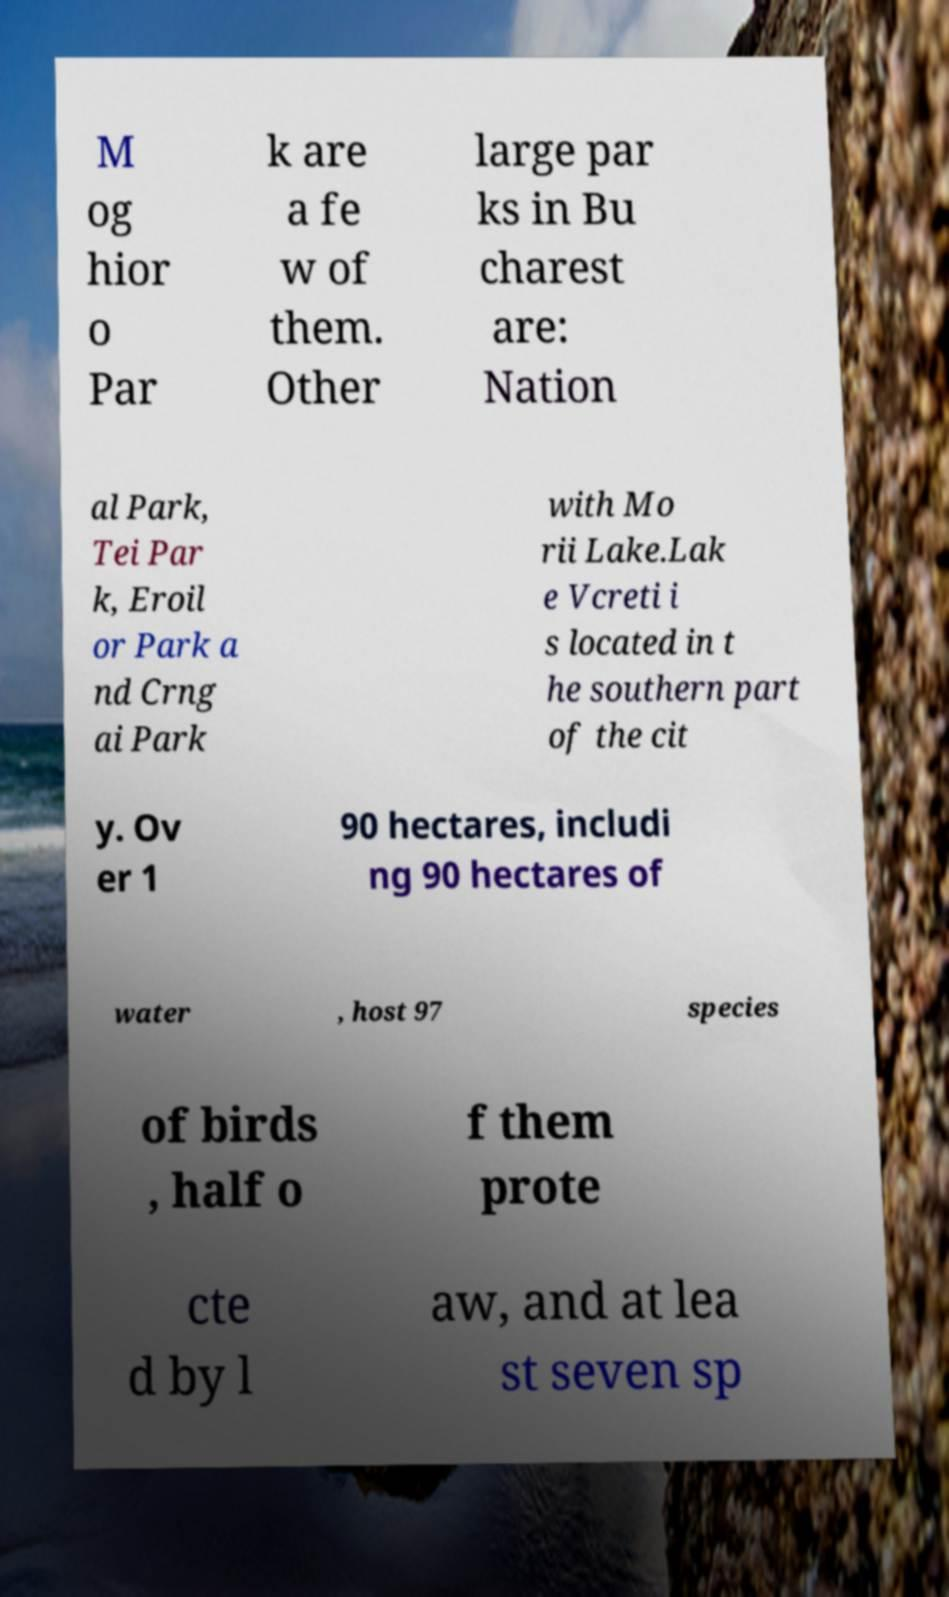There's text embedded in this image that I need extracted. Can you transcribe it verbatim? M og hior o Par k are a fe w of them. Other large par ks in Bu charest are: Nation al Park, Tei Par k, Eroil or Park a nd Crng ai Park with Mo rii Lake.Lak e Vcreti i s located in t he southern part of the cit y. Ov er 1 90 hectares, includi ng 90 hectares of water , host 97 species of birds , half o f them prote cte d by l aw, and at lea st seven sp 